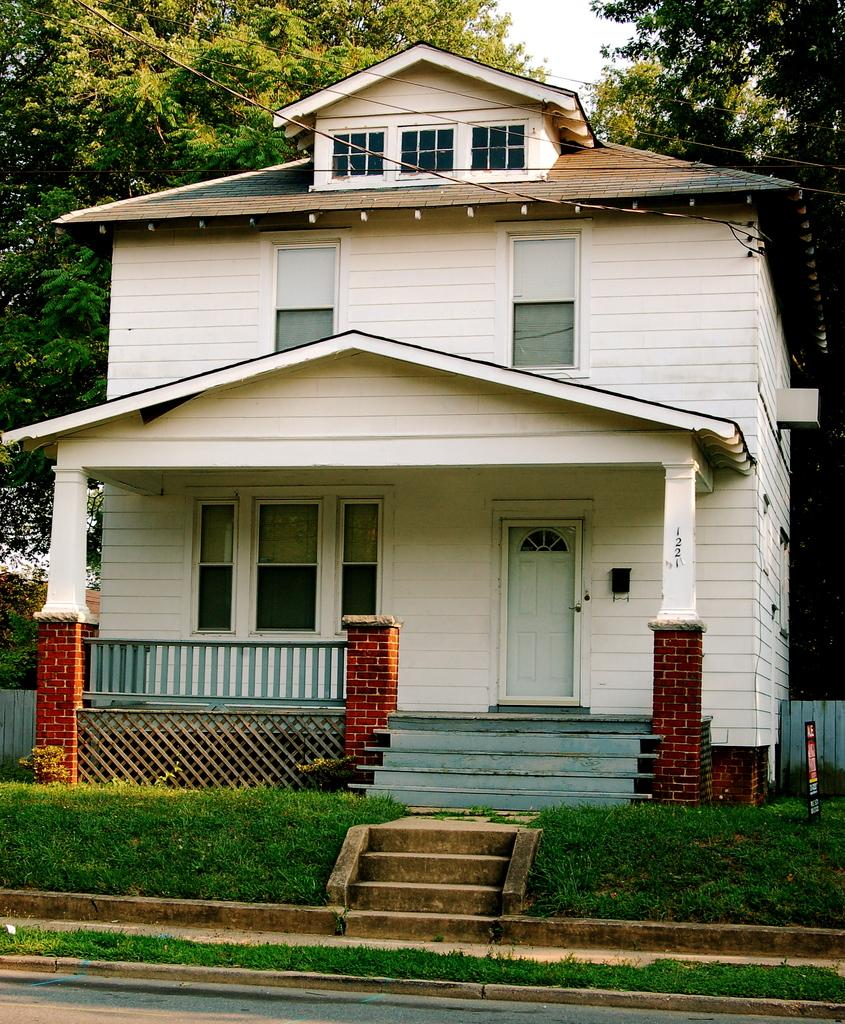What is the main structure in the picture? There is a house in the picture. What type of surface is in front of the house? There is grass on the surface in front of the house. What can be seen at the back side of the house? There are trees at the back side of the house. Where is the library located in the picture? There is no library present in the picture; it only shows a house with grass in front and trees at the back. 